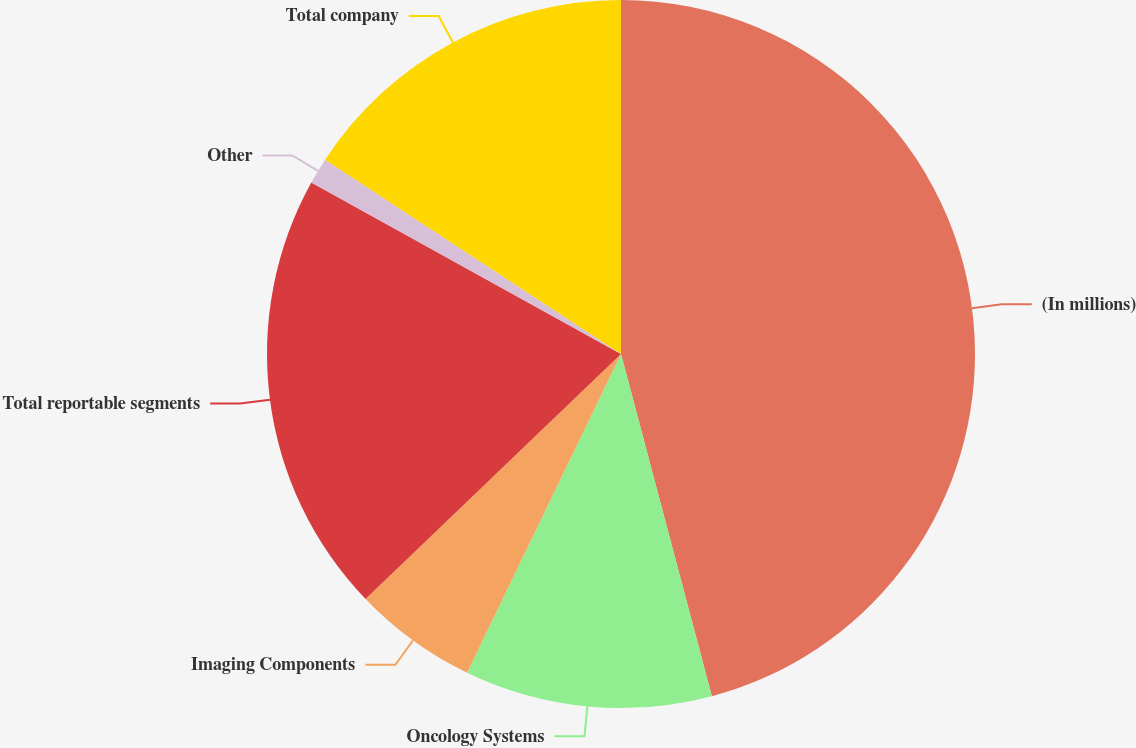<chart> <loc_0><loc_0><loc_500><loc_500><pie_chart><fcel>(In millions)<fcel>Oncology Systems<fcel>Imaging Components<fcel>Total reportable segments<fcel>Other<fcel>Total company<nl><fcel>45.87%<fcel>11.29%<fcel>5.67%<fcel>20.22%<fcel>1.2%<fcel>15.75%<nl></chart> 